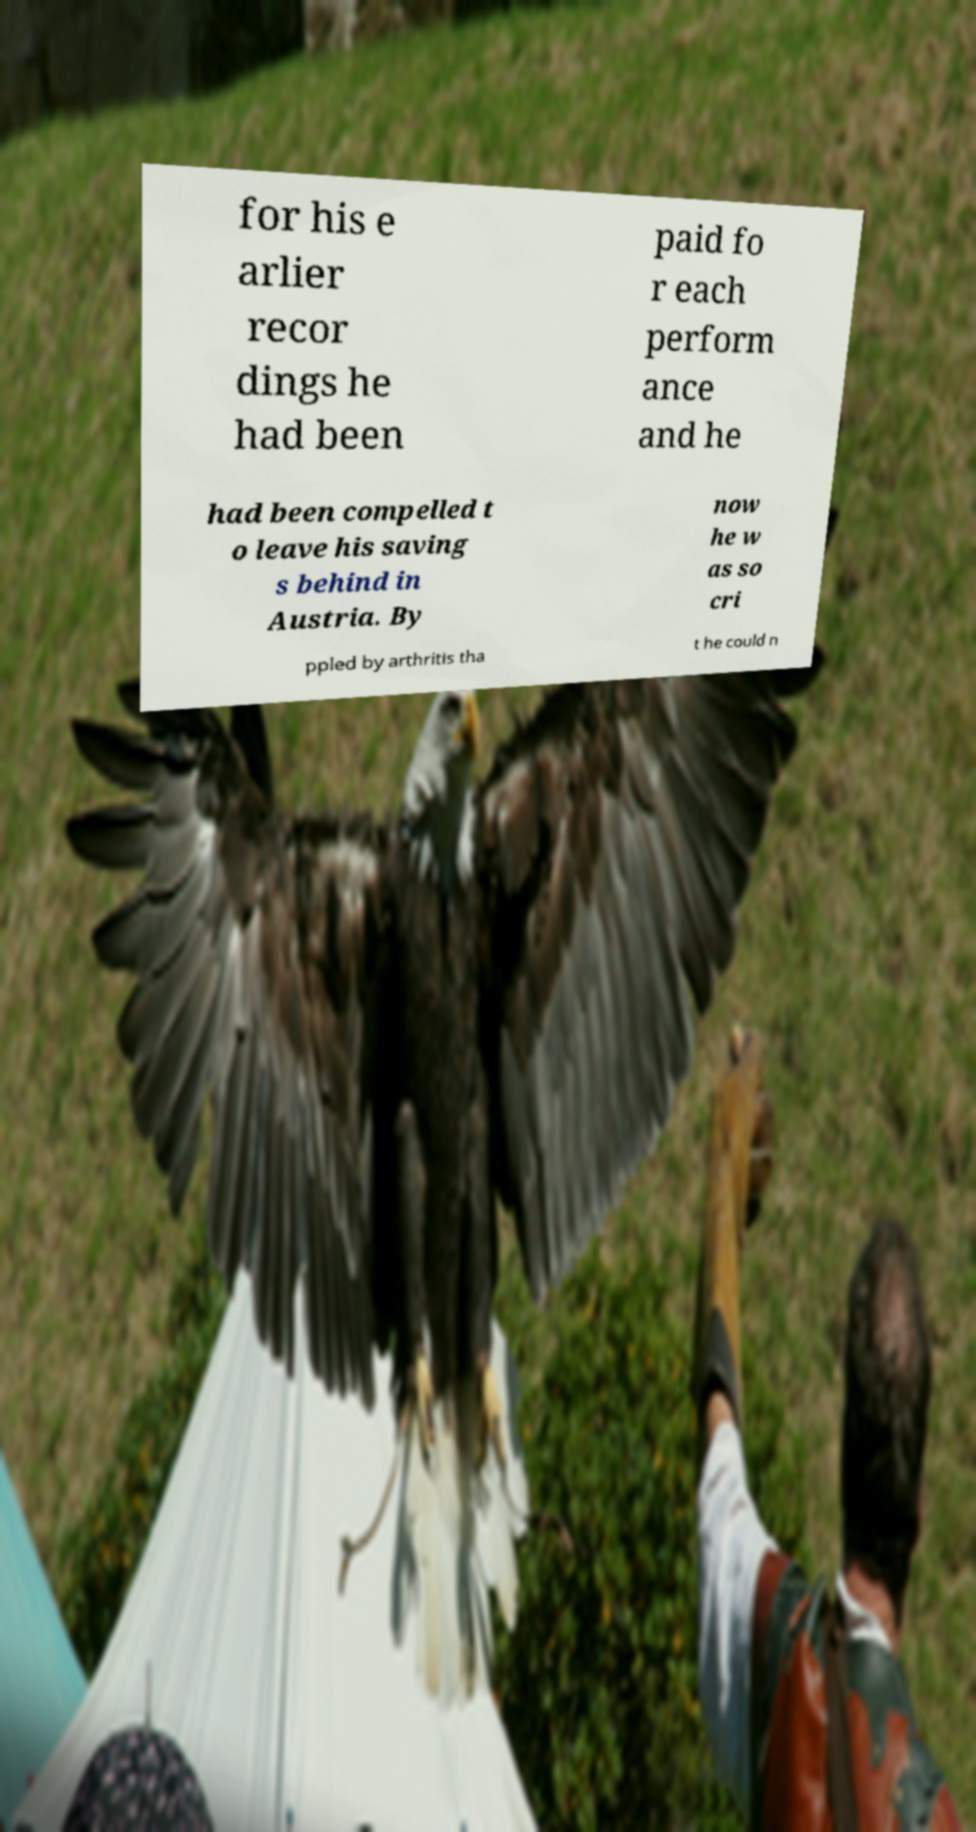Could you extract and type out the text from this image? for his e arlier recor dings he had been paid fo r each perform ance and he had been compelled t o leave his saving s behind in Austria. By now he w as so cri ppled by arthritis tha t he could n 